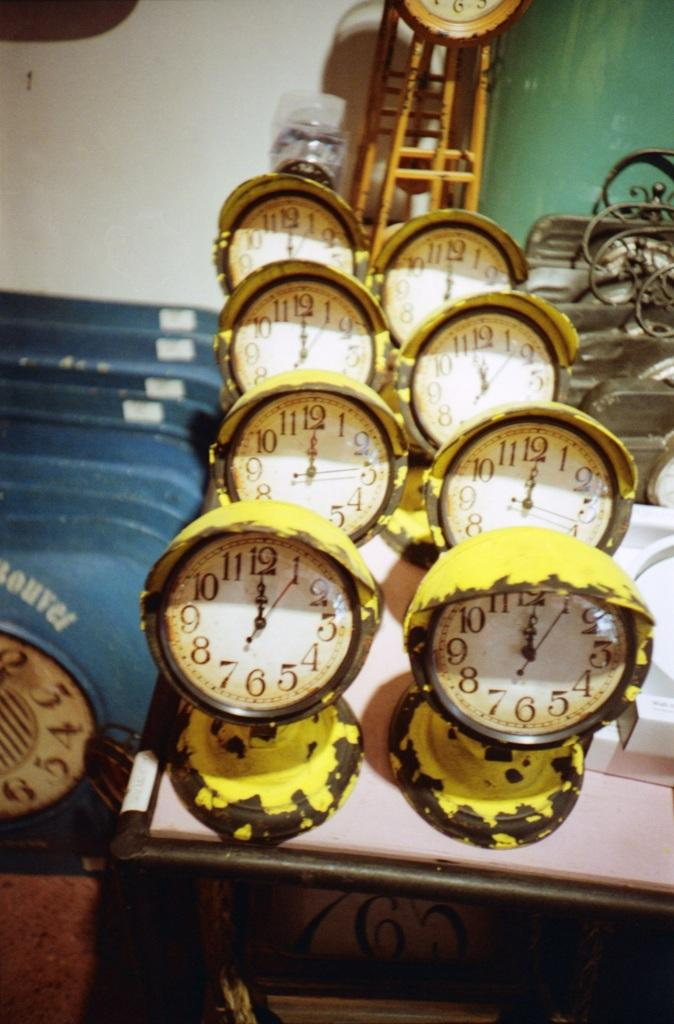<image>
Describe the image concisely. A row of yellow clocks are sitting on a table and they all show the time to be midnight. 